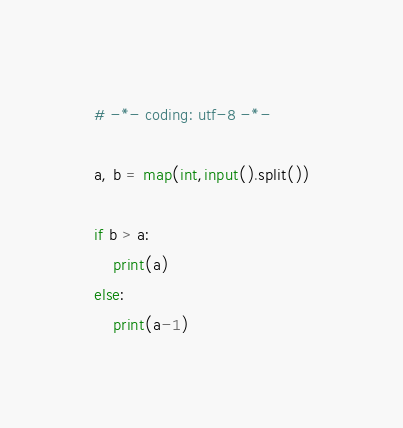Convert code to text. <code><loc_0><loc_0><loc_500><loc_500><_Python_># -*- coding: utf-8 -*-

a, b = map(int,input().split())

if b > a:
    print(a)
else:
    print(a-1)
</code> 